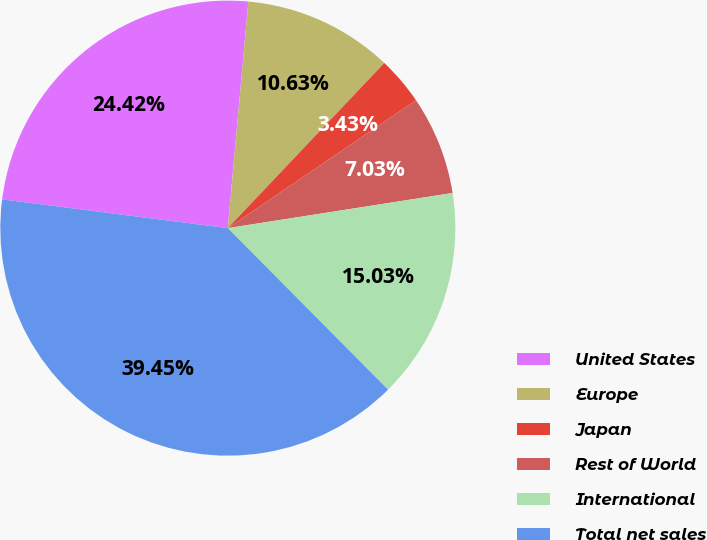Convert chart. <chart><loc_0><loc_0><loc_500><loc_500><pie_chart><fcel>United States<fcel>Europe<fcel>Japan<fcel>Rest of World<fcel>International<fcel>Total net sales<nl><fcel>24.42%<fcel>10.63%<fcel>3.43%<fcel>7.03%<fcel>15.03%<fcel>39.45%<nl></chart> 